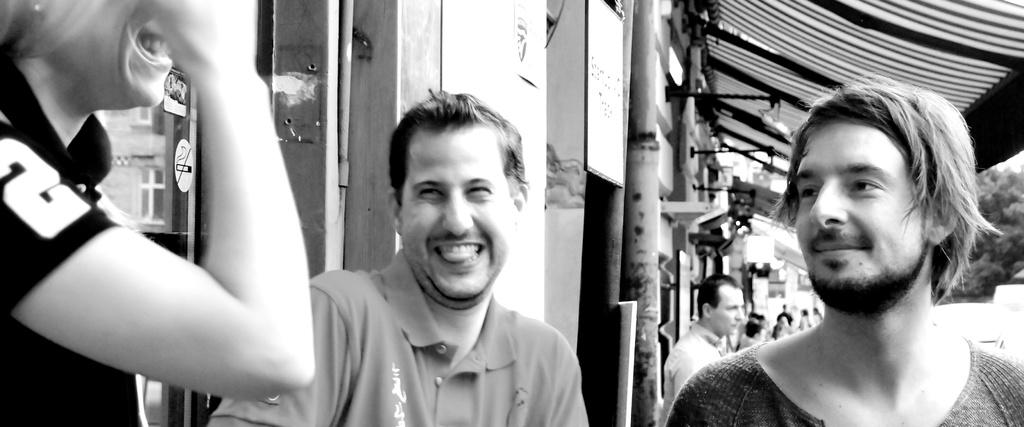Who or what can be seen in the image? There are people in the image. What is the main structure or feature in the image? There is a wall in the image. What is attached to the pole in the image? There is a board on a pole in the image. What can be seen in the distance in the image? Trees are present in the background of the image. How does the country in the image affect the people's behavior? There is no country mentioned or depicted in the image, so it is not possible to determine how it might affect the people's behavior. 